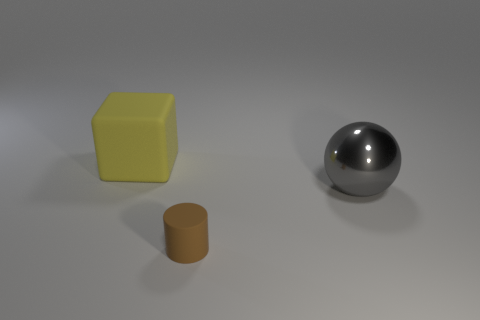Are there any other things of the same color as the tiny thing?
Offer a very short reply. No. What color is the rubber thing in front of the large object behind the big object to the right of the tiny rubber cylinder?
Your answer should be compact. Brown. What number of gray metal things have the same size as the yellow cube?
Make the answer very short. 1. Is the number of large things that are behind the matte cube greater than the number of big rubber objects that are on the left side of the gray object?
Your response must be concise. No. There is a matte object that is left of the matte object that is in front of the yellow rubber object; what is its color?
Your answer should be very brief. Yellow. Is the small brown cylinder made of the same material as the big yellow object?
Offer a terse response. Yes. Do the rubber thing that is behind the tiny brown matte object and the object to the right of the tiny cylinder have the same size?
Offer a very short reply. Yes. The thing that is the same material as the block is what size?
Ensure brevity in your answer.  Small. How many objects are both in front of the big yellow matte block and behind the brown cylinder?
Offer a very short reply. 1. How many things are metallic objects or things that are on the right side of the matte cylinder?
Your answer should be compact. 1. 